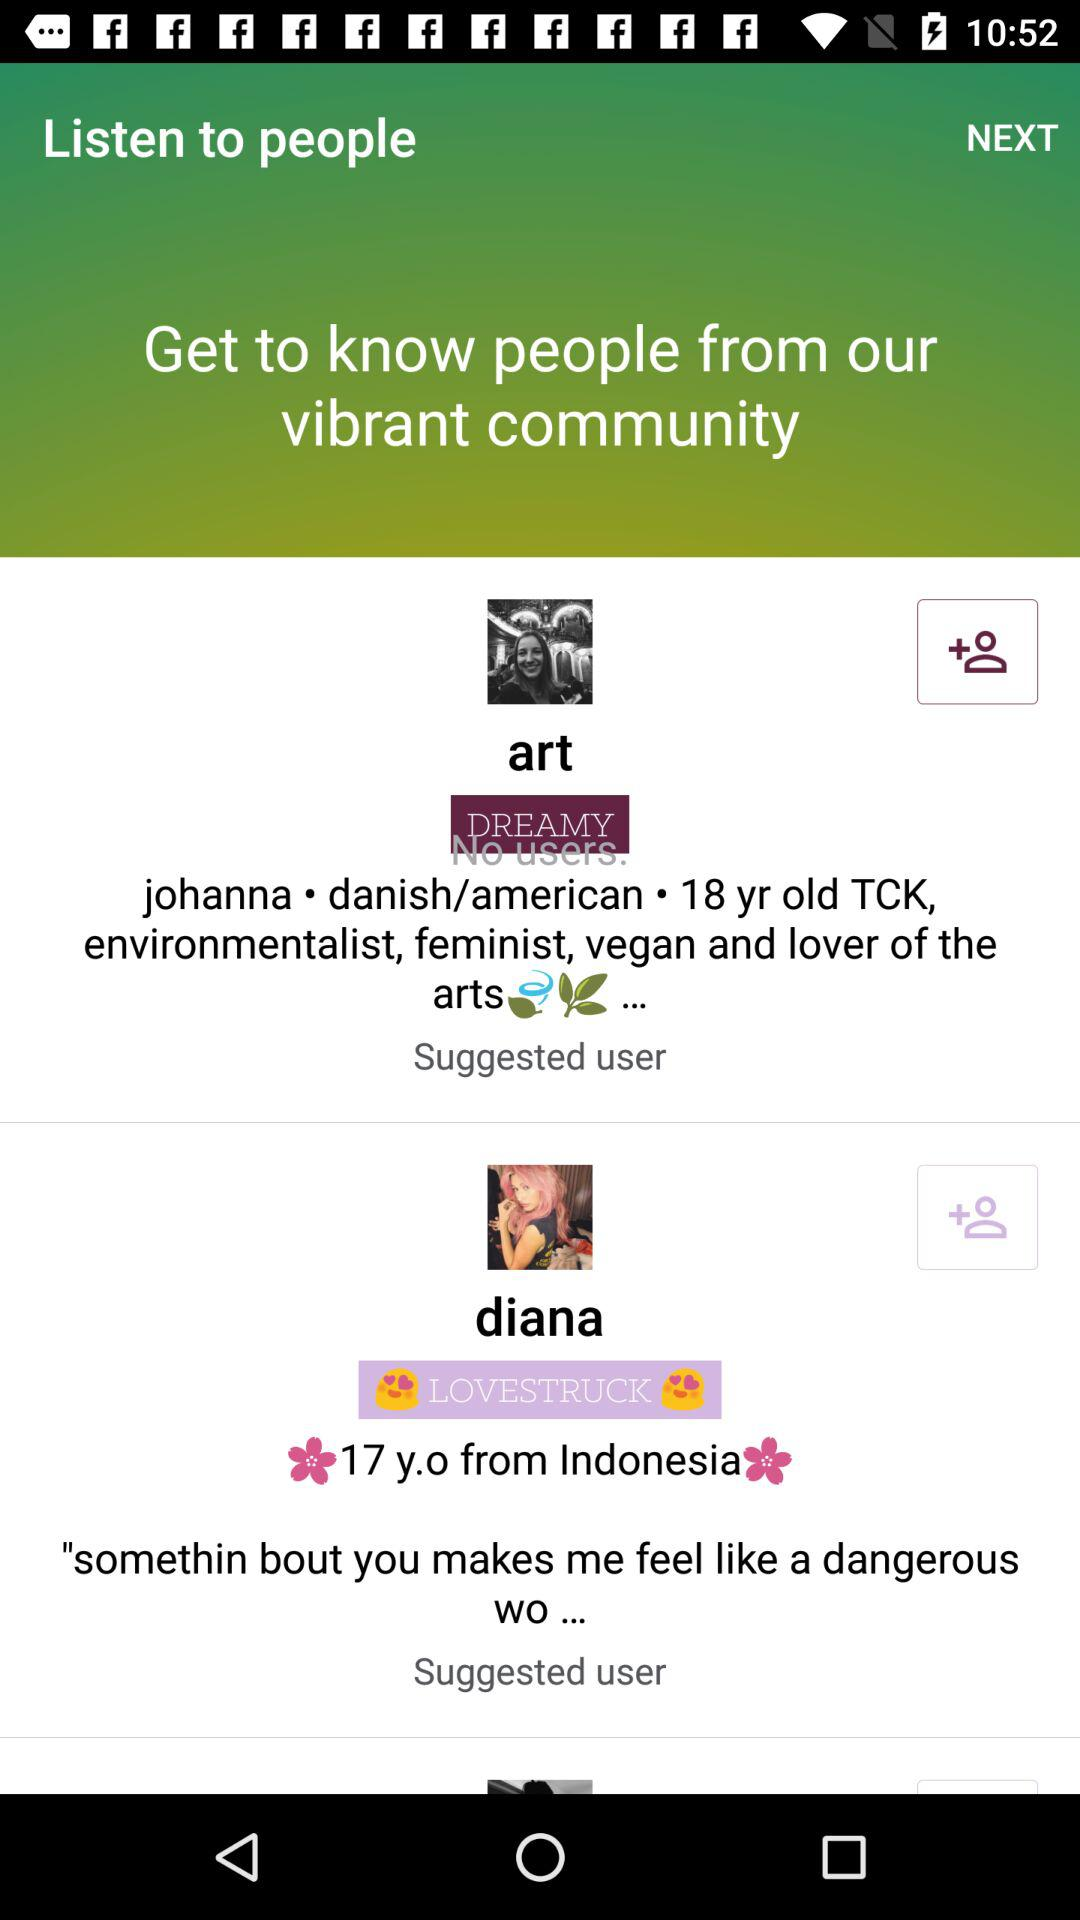Who is the lover of the arts? The lover of the arts is Johanna. 